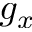<formula> <loc_0><loc_0><loc_500><loc_500>g _ { x }</formula> 